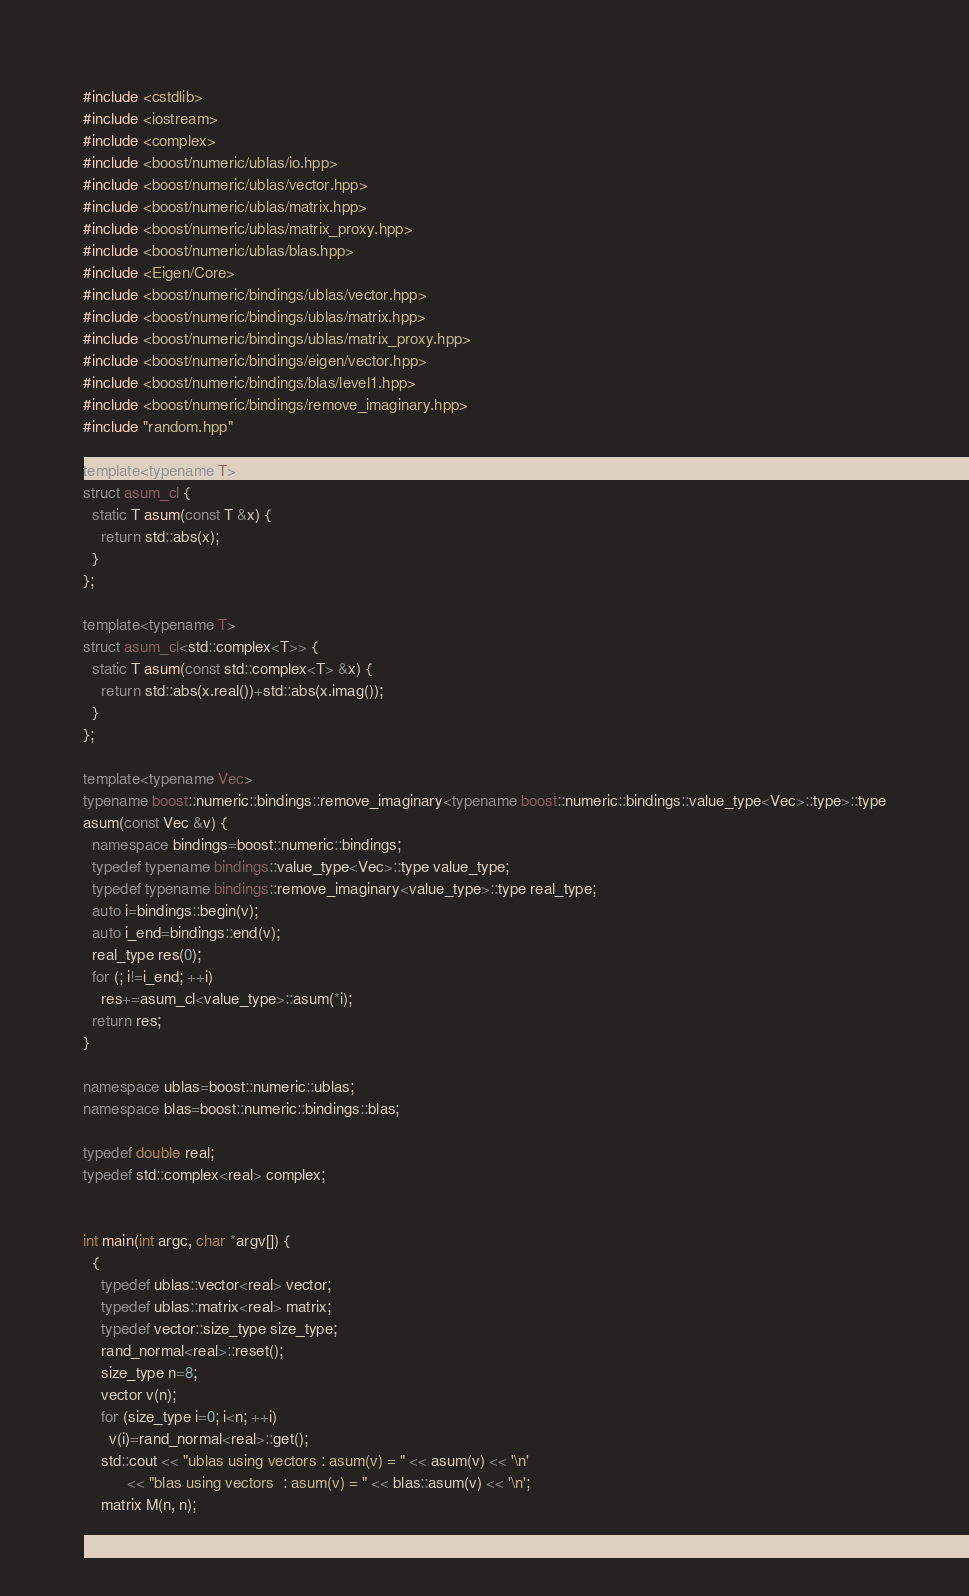Convert code to text. <code><loc_0><loc_0><loc_500><loc_500><_C++_>#include <cstdlib>
#include <iostream>
#include <complex>
#include <boost/numeric/ublas/io.hpp>
#include <boost/numeric/ublas/vector.hpp>
#include <boost/numeric/ublas/matrix.hpp>
#include <boost/numeric/ublas/matrix_proxy.hpp>
#include <boost/numeric/ublas/blas.hpp>
#include <Eigen/Core>
#include <boost/numeric/bindings/ublas/vector.hpp>
#include <boost/numeric/bindings/ublas/matrix.hpp>
#include <boost/numeric/bindings/ublas/matrix_proxy.hpp>
#include <boost/numeric/bindings/eigen/vector.hpp>
#include <boost/numeric/bindings/blas/level1.hpp>
#include <boost/numeric/bindings/remove_imaginary.hpp>
#include "random.hpp"

template<typename T>
struct asum_cl {
  static T asum(const T &x) {
    return std::abs(x);
  }
};

template<typename T>
struct asum_cl<std::complex<T>> {
  static T asum(const std::complex<T> &x) {
    return std::abs(x.real())+std::abs(x.imag());
  }
};

template<typename Vec>
typename boost::numeric::bindings::remove_imaginary<typename boost::numeric::bindings::value_type<Vec>::type>::type
asum(const Vec &v) {
  namespace bindings=boost::numeric::bindings;
  typedef typename bindings::value_type<Vec>::type value_type;
  typedef typename bindings::remove_imaginary<value_type>::type real_type;
  auto i=bindings::begin(v);
  auto i_end=bindings::end(v);
  real_type res(0);
  for (; i!=i_end; ++i)
    res+=asum_cl<value_type>::asum(*i);
  return res;
}

namespace ublas=boost::numeric::ublas;
namespace blas=boost::numeric::bindings::blas;

typedef double real;
typedef std::complex<real> complex;


int main(int argc, char *argv[]) {
  {
    typedef ublas::vector<real> vector;
    typedef ublas::matrix<real> matrix;
    typedef vector::size_type size_type;
    rand_normal<real>::reset();
    size_type n=8;
    vector v(n);
    for (size_type i=0; i<n; ++i)
      v(i)=rand_normal<real>::get();
    std::cout << "ublas using vectors : asum(v) = " << asum(v) << '\n'
	      << "blas using vectors  : asum(v) = " << blas::asum(v) << '\n';
    matrix M(n, n);</code> 